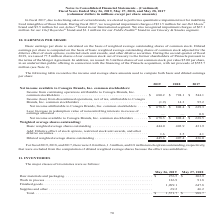According to Conagra Brands's financial document, How is diluted earnings per share computed? on the basis of basic weighted average outstanding shares of common stock adjusted for the dilutive effect of stock options, restricted stock unit awards, and other dilutive securities. The document states: "earnings per share is computed on the basis of basic weighted average outstanding shares of common stock adjusted for the dilutive effect of stock opt..." Also, What was the net income available to Conagra Brands, Inc. common stakeholders in fiscal 2017, 2018, and 2019, respectively? The document contains multiple relevant values: $638.5, $808.4, $678.3 (in millions). From the document: "agra Brands, Inc. common stockholders . $ 678.3 $ 808.4 $ 639.3 nds, Inc. common stockholders . $ 678.3 $ 808.4 $ 638.5 e to Conagra Brands, Inc. comm..." Also, How much was the basic weighted average shares (in million) outstanding in 2018? According to the financial document, 403.9. The relevant text states: "Basic weighted average shares outstanding . 444.0 403.9 431.9..." Also, can you calculate: What is the percentage change in diluted weighted average shares outstanding from 2018 to 2019? To answer this question, I need to perform calculations using the financial data. The calculation is: (445.6-407.4)/407.4 , which equals 9.38 (percentage). This is based on the information: "Diluted weighted average shares outstanding . 445.6 407.4 436.0 luted weighted average shares outstanding . 445.6 407.4 436.0..." The key data points involved are: 407.4, 445.6. Also, can you calculate: What is the ratio of net income available to Conagra Brands, Inc. common stakeholders to diluted weighted average shares outstanding in 2017? Based on the calculation: 638.5/436.0 , the result is 1.46. This is based on the information: "nds, Inc. common stockholders . $ 678.3 $ 808.4 $ 638.5 weighted average shares outstanding . 445.6 407.4 436.0..." The key data points involved are: 436.0, 638.5. Also, can you calculate: What is the proportion of basic weighted average shares outstanding over diluted weighted average shares outstanding in 2018? Based on the calculation: 403.9/407.4 , the result is 0.99. This is based on the information: "Basic weighted average shares outstanding . 444.0 403.9 431.9 luted weighted average shares outstanding . 445.6 407.4 436.0..." The key data points involved are: 403.9, 407.4. 